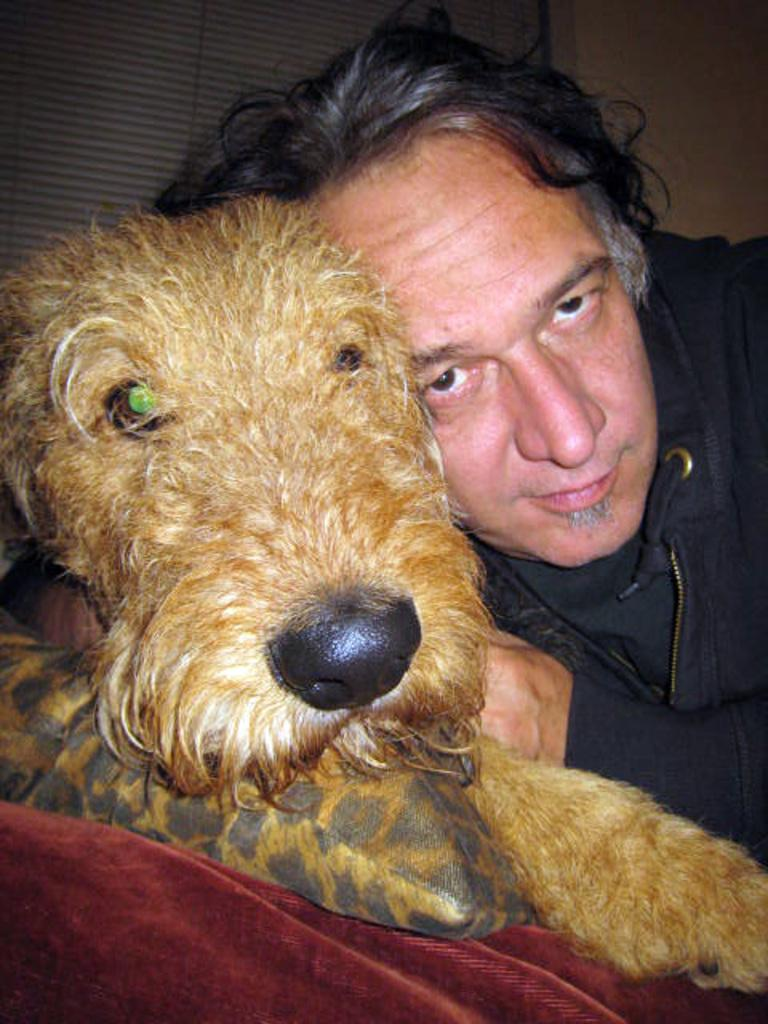What type of animal is in the image? There is a dog in the image. What is the dog doing in the image? The dog is sitting and resting its head on a pillow. Who else is in the image? There is a man in the image. What is the man doing in relation to the dog? The man is sitting beside the dog. What invention is the dog using to stay warm in the image? There is no invention present in the image, and the dog's warmth is not mentioned. 